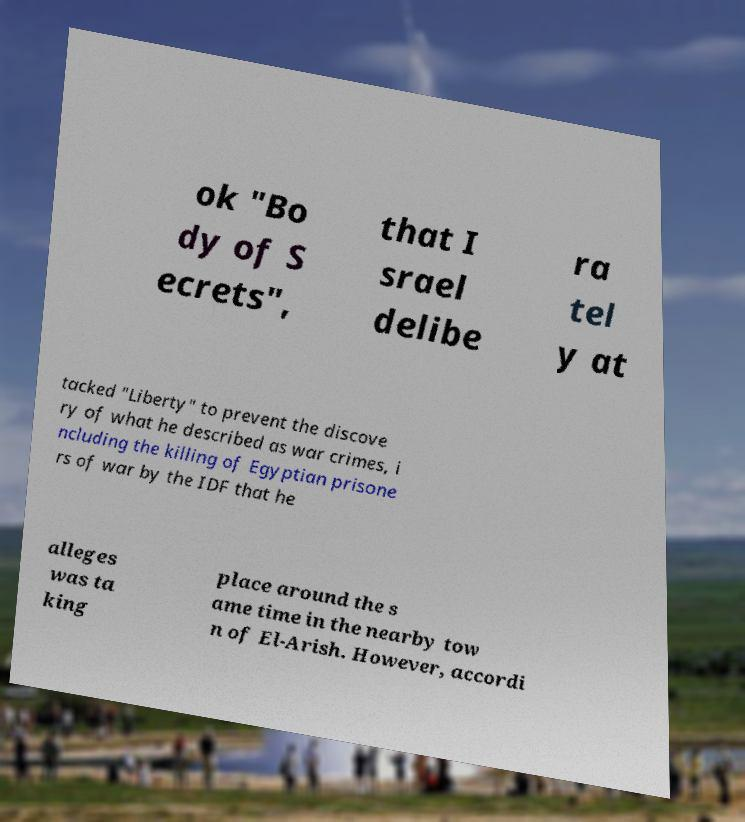Could you assist in decoding the text presented in this image and type it out clearly? ok "Bo dy of S ecrets", that I srael delibe ra tel y at tacked "Liberty" to prevent the discove ry of what he described as war crimes, i ncluding the killing of Egyptian prisone rs of war by the IDF that he alleges was ta king place around the s ame time in the nearby tow n of El-Arish. However, accordi 